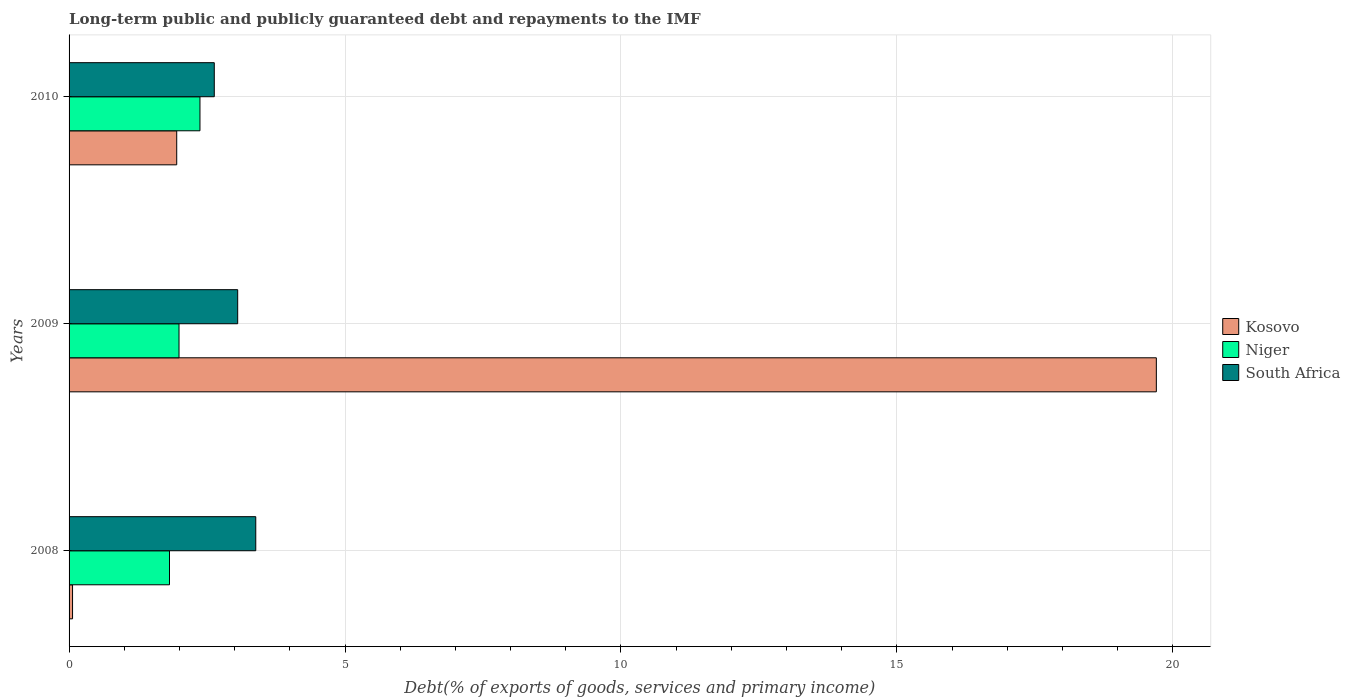How many different coloured bars are there?
Your answer should be compact. 3. Are the number of bars per tick equal to the number of legend labels?
Make the answer very short. Yes. Are the number of bars on each tick of the Y-axis equal?
Your answer should be compact. Yes. How many bars are there on the 2nd tick from the top?
Your answer should be compact. 3. What is the debt and repayments in Kosovo in 2008?
Make the answer very short. 0.06. Across all years, what is the maximum debt and repayments in Kosovo?
Ensure brevity in your answer.  19.7. Across all years, what is the minimum debt and repayments in South Africa?
Ensure brevity in your answer.  2.63. In which year was the debt and repayments in Kosovo maximum?
Your answer should be very brief. 2009. What is the total debt and repayments in South Africa in the graph?
Provide a short and direct response. 9.07. What is the difference between the debt and repayments in South Africa in 2008 and that in 2009?
Your answer should be compact. 0.33. What is the difference between the debt and repayments in Kosovo in 2010 and the debt and repayments in Niger in 2008?
Your answer should be very brief. 0.13. What is the average debt and repayments in South Africa per year?
Offer a very short reply. 3.02. In the year 2009, what is the difference between the debt and repayments in South Africa and debt and repayments in Niger?
Provide a succinct answer. 1.06. In how many years, is the debt and repayments in Kosovo greater than 2 %?
Your answer should be very brief. 1. What is the ratio of the debt and repayments in South Africa in 2008 to that in 2009?
Your answer should be very brief. 1.11. What is the difference between the highest and the second highest debt and repayments in Kosovo?
Offer a very short reply. 17.75. What is the difference between the highest and the lowest debt and repayments in Niger?
Ensure brevity in your answer.  0.55. What does the 1st bar from the top in 2008 represents?
Your answer should be compact. South Africa. What does the 2nd bar from the bottom in 2008 represents?
Give a very brief answer. Niger. Is it the case that in every year, the sum of the debt and repayments in Niger and debt and repayments in South Africa is greater than the debt and repayments in Kosovo?
Keep it short and to the point. No. How many bars are there?
Provide a short and direct response. 9. What is the difference between two consecutive major ticks on the X-axis?
Keep it short and to the point. 5. Are the values on the major ticks of X-axis written in scientific E-notation?
Provide a succinct answer. No. Does the graph contain any zero values?
Provide a short and direct response. No. Where does the legend appear in the graph?
Provide a short and direct response. Center right. What is the title of the graph?
Give a very brief answer. Long-term public and publicly guaranteed debt and repayments to the IMF. Does "Uganda" appear as one of the legend labels in the graph?
Provide a succinct answer. No. What is the label or title of the X-axis?
Your response must be concise. Debt(% of exports of goods, services and primary income). What is the Debt(% of exports of goods, services and primary income) of Kosovo in 2008?
Provide a short and direct response. 0.06. What is the Debt(% of exports of goods, services and primary income) in Niger in 2008?
Make the answer very short. 1.82. What is the Debt(% of exports of goods, services and primary income) of South Africa in 2008?
Make the answer very short. 3.38. What is the Debt(% of exports of goods, services and primary income) of Kosovo in 2009?
Make the answer very short. 19.7. What is the Debt(% of exports of goods, services and primary income) of Niger in 2009?
Provide a succinct answer. 1.99. What is the Debt(% of exports of goods, services and primary income) of South Africa in 2009?
Offer a terse response. 3.06. What is the Debt(% of exports of goods, services and primary income) in Kosovo in 2010?
Your answer should be very brief. 1.95. What is the Debt(% of exports of goods, services and primary income) of Niger in 2010?
Provide a short and direct response. 2.37. What is the Debt(% of exports of goods, services and primary income) in South Africa in 2010?
Your response must be concise. 2.63. Across all years, what is the maximum Debt(% of exports of goods, services and primary income) in Kosovo?
Provide a short and direct response. 19.7. Across all years, what is the maximum Debt(% of exports of goods, services and primary income) of Niger?
Keep it short and to the point. 2.37. Across all years, what is the maximum Debt(% of exports of goods, services and primary income) in South Africa?
Offer a very short reply. 3.38. Across all years, what is the minimum Debt(% of exports of goods, services and primary income) of Kosovo?
Your response must be concise. 0.06. Across all years, what is the minimum Debt(% of exports of goods, services and primary income) of Niger?
Keep it short and to the point. 1.82. Across all years, what is the minimum Debt(% of exports of goods, services and primary income) in South Africa?
Offer a terse response. 2.63. What is the total Debt(% of exports of goods, services and primary income) in Kosovo in the graph?
Offer a terse response. 21.72. What is the total Debt(% of exports of goods, services and primary income) in Niger in the graph?
Keep it short and to the point. 6.18. What is the total Debt(% of exports of goods, services and primary income) of South Africa in the graph?
Offer a very short reply. 9.07. What is the difference between the Debt(% of exports of goods, services and primary income) in Kosovo in 2008 and that in 2009?
Offer a terse response. -19.64. What is the difference between the Debt(% of exports of goods, services and primary income) in Niger in 2008 and that in 2009?
Ensure brevity in your answer.  -0.17. What is the difference between the Debt(% of exports of goods, services and primary income) in South Africa in 2008 and that in 2009?
Your response must be concise. 0.33. What is the difference between the Debt(% of exports of goods, services and primary income) of Kosovo in 2008 and that in 2010?
Your response must be concise. -1.89. What is the difference between the Debt(% of exports of goods, services and primary income) in Niger in 2008 and that in 2010?
Keep it short and to the point. -0.55. What is the difference between the Debt(% of exports of goods, services and primary income) of South Africa in 2008 and that in 2010?
Make the answer very short. 0.75. What is the difference between the Debt(% of exports of goods, services and primary income) in Kosovo in 2009 and that in 2010?
Provide a succinct answer. 17.75. What is the difference between the Debt(% of exports of goods, services and primary income) of Niger in 2009 and that in 2010?
Ensure brevity in your answer.  -0.38. What is the difference between the Debt(% of exports of goods, services and primary income) of South Africa in 2009 and that in 2010?
Provide a succinct answer. 0.42. What is the difference between the Debt(% of exports of goods, services and primary income) in Kosovo in 2008 and the Debt(% of exports of goods, services and primary income) in Niger in 2009?
Your answer should be compact. -1.93. What is the difference between the Debt(% of exports of goods, services and primary income) in Kosovo in 2008 and the Debt(% of exports of goods, services and primary income) in South Africa in 2009?
Your answer should be very brief. -2.99. What is the difference between the Debt(% of exports of goods, services and primary income) in Niger in 2008 and the Debt(% of exports of goods, services and primary income) in South Africa in 2009?
Your response must be concise. -1.24. What is the difference between the Debt(% of exports of goods, services and primary income) of Kosovo in 2008 and the Debt(% of exports of goods, services and primary income) of Niger in 2010?
Make the answer very short. -2.31. What is the difference between the Debt(% of exports of goods, services and primary income) of Kosovo in 2008 and the Debt(% of exports of goods, services and primary income) of South Africa in 2010?
Give a very brief answer. -2.57. What is the difference between the Debt(% of exports of goods, services and primary income) in Niger in 2008 and the Debt(% of exports of goods, services and primary income) in South Africa in 2010?
Your response must be concise. -0.81. What is the difference between the Debt(% of exports of goods, services and primary income) in Kosovo in 2009 and the Debt(% of exports of goods, services and primary income) in Niger in 2010?
Ensure brevity in your answer.  17.33. What is the difference between the Debt(% of exports of goods, services and primary income) of Kosovo in 2009 and the Debt(% of exports of goods, services and primary income) of South Africa in 2010?
Keep it short and to the point. 17.07. What is the difference between the Debt(% of exports of goods, services and primary income) in Niger in 2009 and the Debt(% of exports of goods, services and primary income) in South Africa in 2010?
Ensure brevity in your answer.  -0.64. What is the average Debt(% of exports of goods, services and primary income) in Kosovo per year?
Your response must be concise. 7.24. What is the average Debt(% of exports of goods, services and primary income) of Niger per year?
Ensure brevity in your answer.  2.06. What is the average Debt(% of exports of goods, services and primary income) of South Africa per year?
Ensure brevity in your answer.  3.02. In the year 2008, what is the difference between the Debt(% of exports of goods, services and primary income) in Kosovo and Debt(% of exports of goods, services and primary income) in Niger?
Provide a succinct answer. -1.76. In the year 2008, what is the difference between the Debt(% of exports of goods, services and primary income) of Kosovo and Debt(% of exports of goods, services and primary income) of South Africa?
Provide a short and direct response. -3.32. In the year 2008, what is the difference between the Debt(% of exports of goods, services and primary income) in Niger and Debt(% of exports of goods, services and primary income) in South Africa?
Give a very brief answer. -1.56. In the year 2009, what is the difference between the Debt(% of exports of goods, services and primary income) in Kosovo and Debt(% of exports of goods, services and primary income) in Niger?
Your answer should be very brief. 17.71. In the year 2009, what is the difference between the Debt(% of exports of goods, services and primary income) of Kosovo and Debt(% of exports of goods, services and primary income) of South Africa?
Your answer should be very brief. 16.65. In the year 2009, what is the difference between the Debt(% of exports of goods, services and primary income) of Niger and Debt(% of exports of goods, services and primary income) of South Africa?
Ensure brevity in your answer.  -1.06. In the year 2010, what is the difference between the Debt(% of exports of goods, services and primary income) of Kosovo and Debt(% of exports of goods, services and primary income) of Niger?
Provide a succinct answer. -0.42. In the year 2010, what is the difference between the Debt(% of exports of goods, services and primary income) in Kosovo and Debt(% of exports of goods, services and primary income) in South Africa?
Your response must be concise. -0.68. In the year 2010, what is the difference between the Debt(% of exports of goods, services and primary income) of Niger and Debt(% of exports of goods, services and primary income) of South Africa?
Your answer should be very brief. -0.26. What is the ratio of the Debt(% of exports of goods, services and primary income) of Kosovo in 2008 to that in 2009?
Your answer should be compact. 0. What is the ratio of the Debt(% of exports of goods, services and primary income) of Niger in 2008 to that in 2009?
Your answer should be very brief. 0.91. What is the ratio of the Debt(% of exports of goods, services and primary income) of South Africa in 2008 to that in 2009?
Your answer should be very brief. 1.11. What is the ratio of the Debt(% of exports of goods, services and primary income) of Kosovo in 2008 to that in 2010?
Ensure brevity in your answer.  0.03. What is the ratio of the Debt(% of exports of goods, services and primary income) of Niger in 2008 to that in 2010?
Make the answer very short. 0.77. What is the ratio of the Debt(% of exports of goods, services and primary income) in South Africa in 2008 to that in 2010?
Offer a terse response. 1.29. What is the ratio of the Debt(% of exports of goods, services and primary income) of Kosovo in 2009 to that in 2010?
Ensure brevity in your answer.  10.1. What is the ratio of the Debt(% of exports of goods, services and primary income) of Niger in 2009 to that in 2010?
Make the answer very short. 0.84. What is the ratio of the Debt(% of exports of goods, services and primary income) of South Africa in 2009 to that in 2010?
Provide a short and direct response. 1.16. What is the difference between the highest and the second highest Debt(% of exports of goods, services and primary income) of Kosovo?
Provide a short and direct response. 17.75. What is the difference between the highest and the second highest Debt(% of exports of goods, services and primary income) of Niger?
Your response must be concise. 0.38. What is the difference between the highest and the second highest Debt(% of exports of goods, services and primary income) of South Africa?
Your answer should be compact. 0.33. What is the difference between the highest and the lowest Debt(% of exports of goods, services and primary income) of Kosovo?
Your answer should be very brief. 19.64. What is the difference between the highest and the lowest Debt(% of exports of goods, services and primary income) in Niger?
Your response must be concise. 0.55. What is the difference between the highest and the lowest Debt(% of exports of goods, services and primary income) in South Africa?
Offer a very short reply. 0.75. 